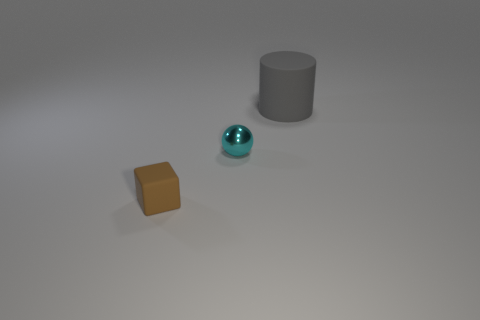Add 2 small gray cylinders. How many objects exist? 5 Add 3 tiny brown things. How many tiny brown things are left? 4 Add 2 large gray objects. How many large gray objects exist? 3 Subtract 0 green spheres. How many objects are left? 3 Subtract all cylinders. How many objects are left? 2 Subtract all large gray things. Subtract all spheres. How many objects are left? 1 